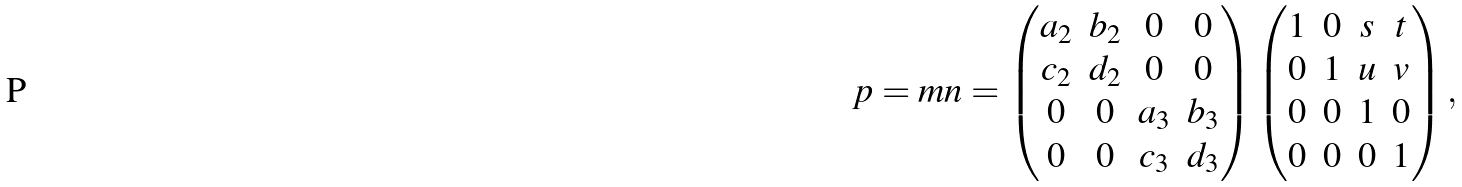Convert formula to latex. <formula><loc_0><loc_0><loc_500><loc_500>p = m n = \left ( \begin{matrix} a _ { 2 } & b _ { 2 } & 0 & 0 \\ c _ { 2 } & d _ { 2 } & 0 & 0 \\ 0 & 0 & a _ { 3 } & b _ { 3 } \\ 0 & 0 & c _ { 3 } & d _ { 3 } \end{matrix} \right ) \left ( \begin{matrix} 1 & 0 & s & t \\ 0 & 1 & u & v \\ 0 & 0 & 1 & 0 \\ 0 & 0 & 0 & 1 \end{matrix} \right ) ,</formula> 